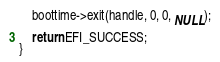Convert code to text. <code><loc_0><loc_0><loc_500><loc_500><_C_>	boottime->exit(handle, 0, 0, NULL);

	return EFI_SUCCESS;
}
</code> 